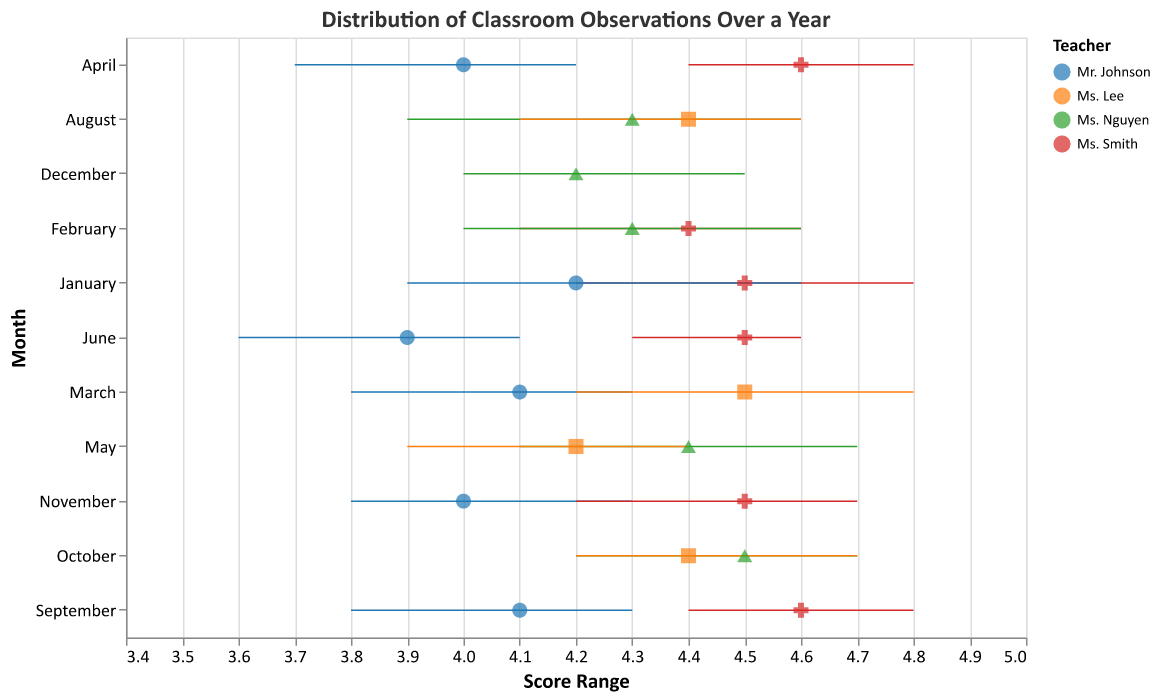What is the highest average score achieved and by which teacher? The highest average score is 4.6, which was achieved by Ms. Smith in April and September. To determine this, I scanned through the plot and found the highest individual average score points.
Answer: 4.6 by Ms. Smith Which month had the most observations for Mr. Johnson? In September, Mr. Johnson had the most observations, with a total of 4. This is determined by locating Mr. Johnson's data points and finding the month with the highest number of observations.
Answer: September What is the range of scores for Ms. Nguyen in December? The range of scores for Ms. Nguyen in December is between 4.0 and 4.5. This is determined by looking at the rule for Ms. Nguyen in December and noting the lowest and highest scores.
Answer: 4.0 to 4.5 On average, did Ms. Lee have consistently high scores throughout the year? Ms. Lee's average scores varied slightly but remained consistently within a high range of 4.2 to 4.5. Examining Ms. Lee's plotted points, average scores can be identified as consistently at the higher end of the score spectrum.
Answer: Yes Which teacher had the widest range of scores in any single month, and what was that range? Mr. Johnson in June had the widest range of scores, from 3.6 to 4.1, giving a range of 0.5. This is found by identifying the teacher-month combinations with the widest horizontal rule.
Answer: Mr. Johnson, 0.5 Compare the average scores of Ms. Smith between January and June. How do they differ? In January, Ms. Smith’s average score was 4.5, whereas in June, it was also 4.5. Reviewing Ms. Smith's plotted points in January and June, the average scores are noted to be the same.
Answer: They are the same In which month did Ms. Nguyen achieve her highest average score and what was the value? Ms. Nguyen achieved her highest average score in October, with an average score of 4.5. This is determined by examining all of Ms. Nguyen’s plotted points for their average score.
Answer: October, 4.5 Which month had the most variation in scores for Ms. Lee? Ms. Lee had the most variation in her scores in May, with scores ranging from 3.9 to 4.4. By examining the length of the horizontal rules for Ms. Lee, May shows the greatest span.
Answer: May Who had the lowest score in September and what was the value? Mr. Johnson had the lowest score in September, with a lowest score of 3.8. This is found by finding the lowest points on the rule marks in September.
Answer: Mr. Johnson, 3.8 How many observations did Ms. Smith have in November and what was her average score for that month? Ms. Smith had 4 observations in November, with an average score of 4.5. This information can be found in the tooltip or near the data point for November.
Answer: 4 observations, 4.5 